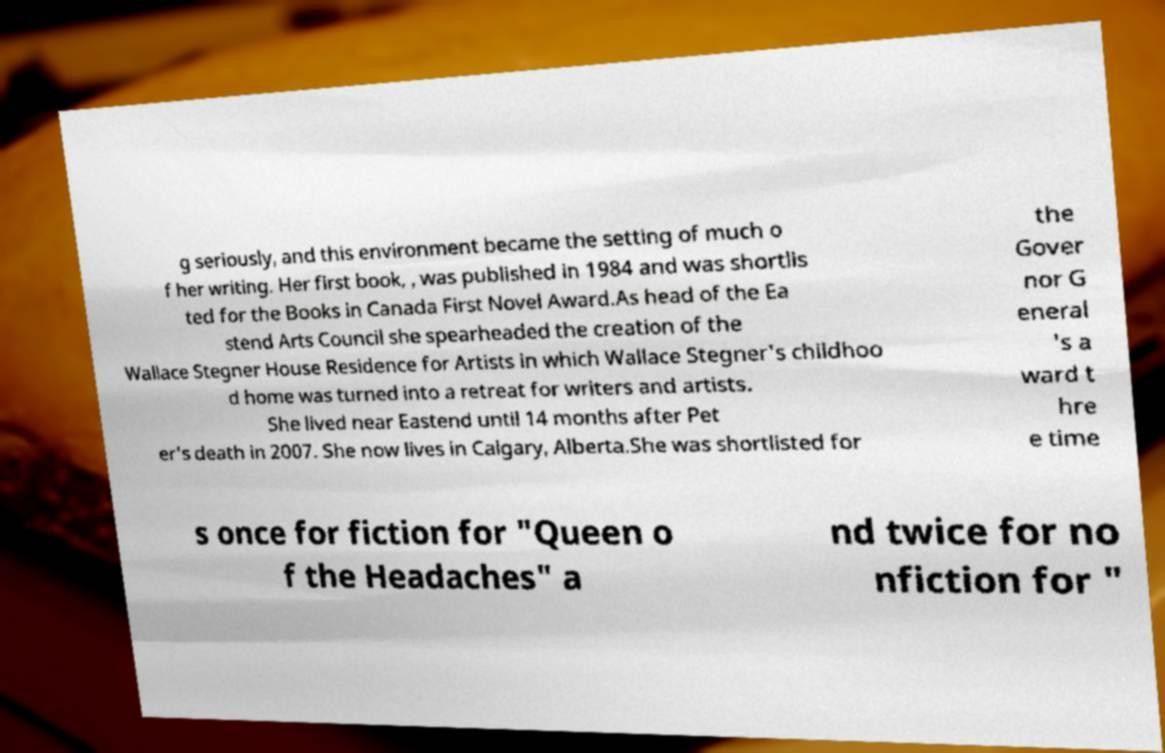Please read and relay the text visible in this image. What does it say? g seriously, and this environment became the setting of much o f her writing. Her first book, , was published in 1984 and was shortlis ted for the Books in Canada First Novel Award.As head of the Ea stend Arts Council she spearheaded the creation of the Wallace Stegner House Residence for Artists in which Wallace Stegner's childhoo d home was turned into a retreat for writers and artists. She lived near Eastend until 14 months after Pet er's death in 2007. She now lives in Calgary, Alberta.She was shortlisted for the Gover nor G eneral 's a ward t hre e time s once for fiction for "Queen o f the Headaches" a nd twice for no nfiction for " 